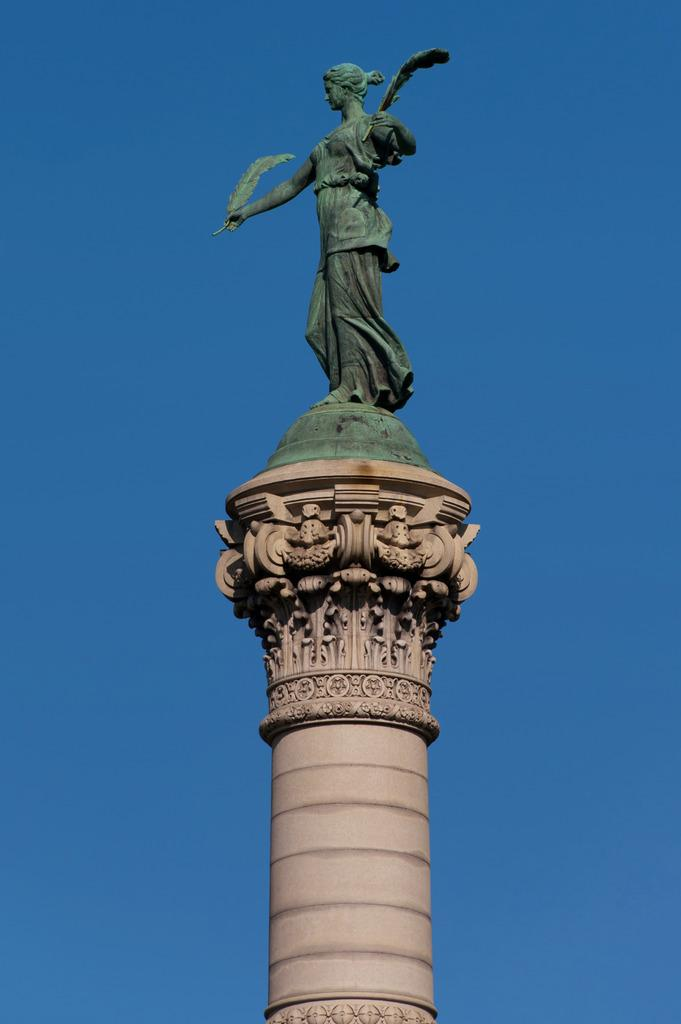What is the main structure in the image? There is a pillar with sculptures in the image. What is on top of the pillar? There is a statue on top of the pillar. What color is the background of the image? The background of the image is blue. What type of harmony can be heard in the image? There is no sound or music present in the image, so it is not possible to determine if any harmony can be heard. 